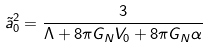<formula> <loc_0><loc_0><loc_500><loc_500>\tilde { a } _ { 0 } ^ { 2 } = \frac { 3 } { \Lambda + 8 \pi G _ { N } V _ { 0 } + 8 \pi G _ { N } \alpha }</formula> 